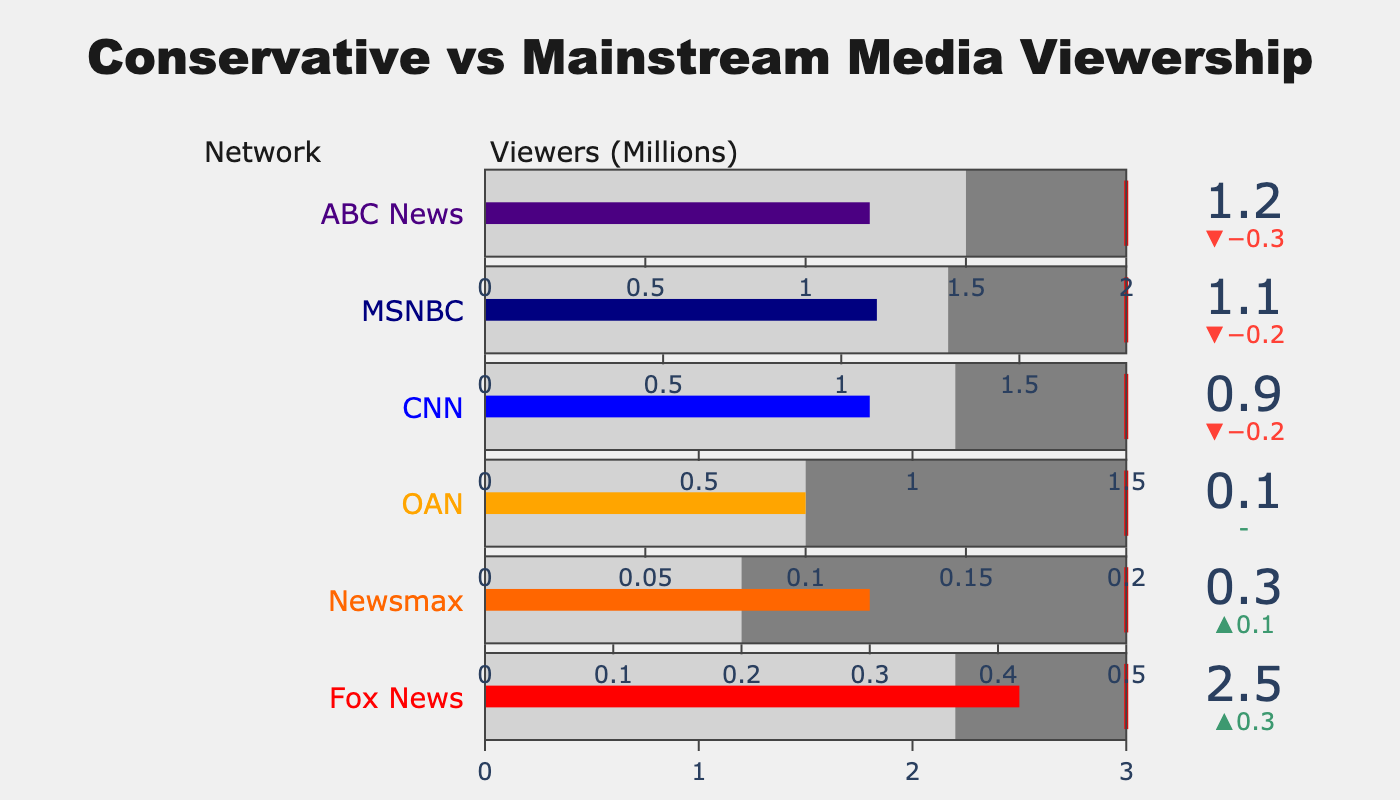What is the title of the figure? The title of the figure can be directly read from the top section of the image.
Answer: Conservative vs Mainstream Media Viewership How many networks are displayed in the chart? By counting the number of different indicators or rows representing networks, we see there are six.
Answer: 6 Which network has the highest actual viewers? By looking at the values of the actual viewers shown on each indicator, Fox News has the highest with 2.5 million viewers.
Answer: Fox News What is the target viewer count for CNN? The target viewer count for CNN is indicated by its red threshold line, which is marked at 1.5 million viewers.
Answer: 1.5 million viewers Which network has the smallest difference between its actual viewers and average viewers? By evaluating the delta values (difference between actual and average viewers), OAN has a difference of 0.0 (0.1 actual - 0.1 average).
Answer: OAN How does the actual viewership of Fox News compare to its target viewers? Fox News' actual viewers (2.5 million) are less than its target viewers (3.0 million), as indicated by the bar not reaching the threshold line.
Answer: Less than Which network comes closest to meeting its target viewers among the conservative media outlets? Comparing the proximity of actual values to target values, Newsmax (0.3 actual vs 0.5 target) is closest among conservative networks.
Answer: Newsmax What is the average viewership for ABC News? The average viewership for ABC News is shown as a step range in gray up to 1.5 million viewers.
Answer: 1.5 million viewers Which mainstream network has more actual viewers, CNN or MSNBC? By comparing the actual viewer values, MSNBC has 1.1 million, while CNN has 0.9 million, making MSNBC the one with more actual viewers.
Answer: MSNBC By how much does ABC News’ actual viewers fall short of its target viewers? The actual viewers for ABC News are 1.2 million, and the target viewers are 2.0 million. Subtracting these gives a shortfall of 0.8 million viewers.
Answer: 0.8 million viewers 